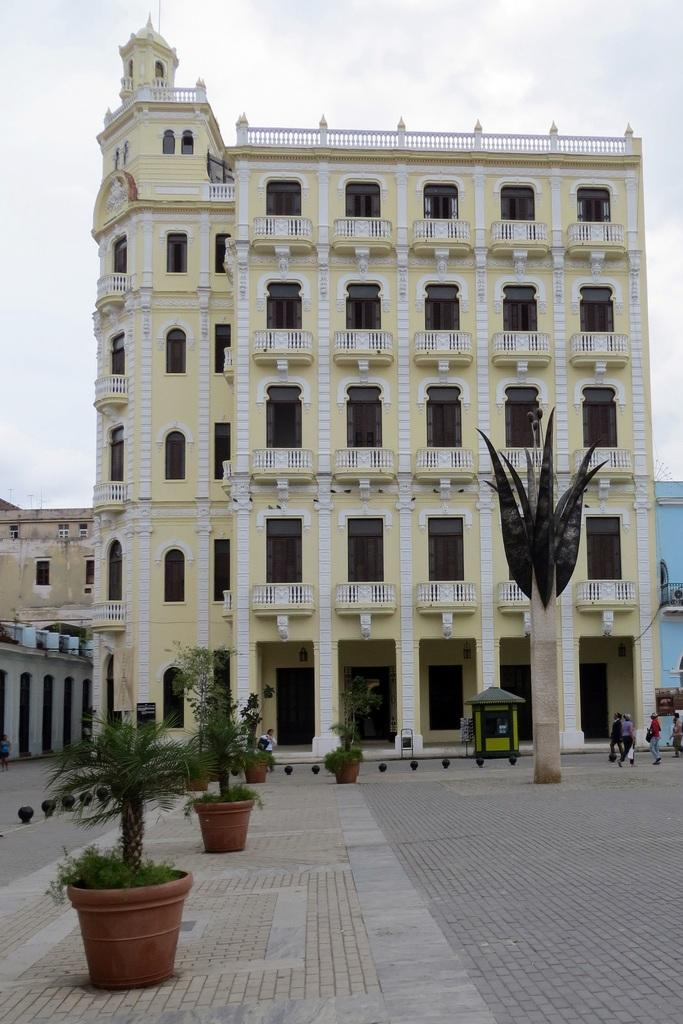What type of structure is visible in the image? There is a building in the image. What features can be seen on the building? The building has windows and doors. What is located on the left side of the image? There are plants on the left side of the image. What is happening on the right side of the image? There are people walking on the right side of the image. What is the condition of the sky in the image? The sky is clear in the image. Where is the toothbrush located in the image? There is no toothbrush present in the image. What type of amusement can be seen in the image? There is no amusement depicted in the image; it features a building, plants, people walking, and a clear sky. 